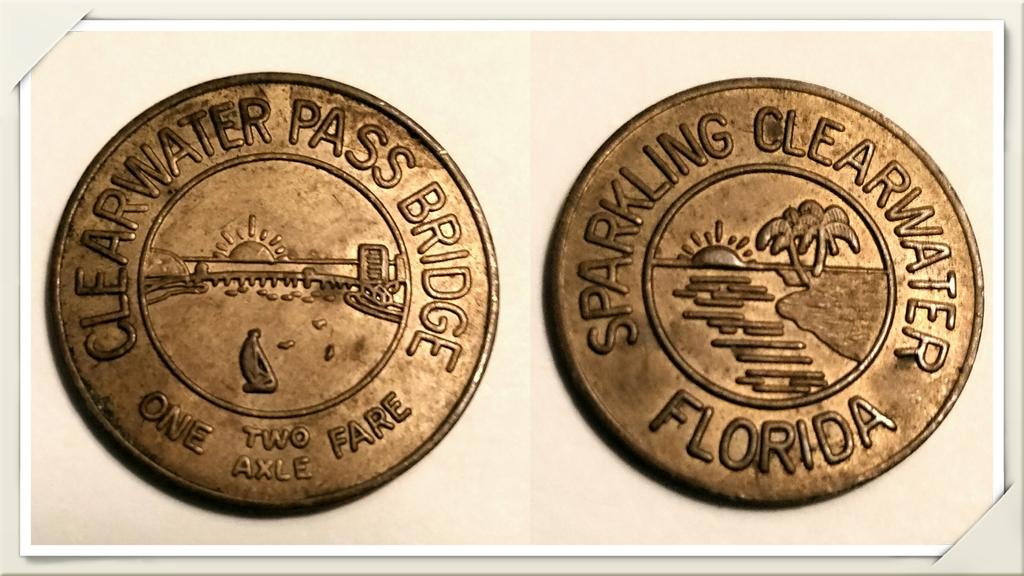Where is the bridge located?
Offer a very short reply. Florida. How many axle?
Your response must be concise. Two. 